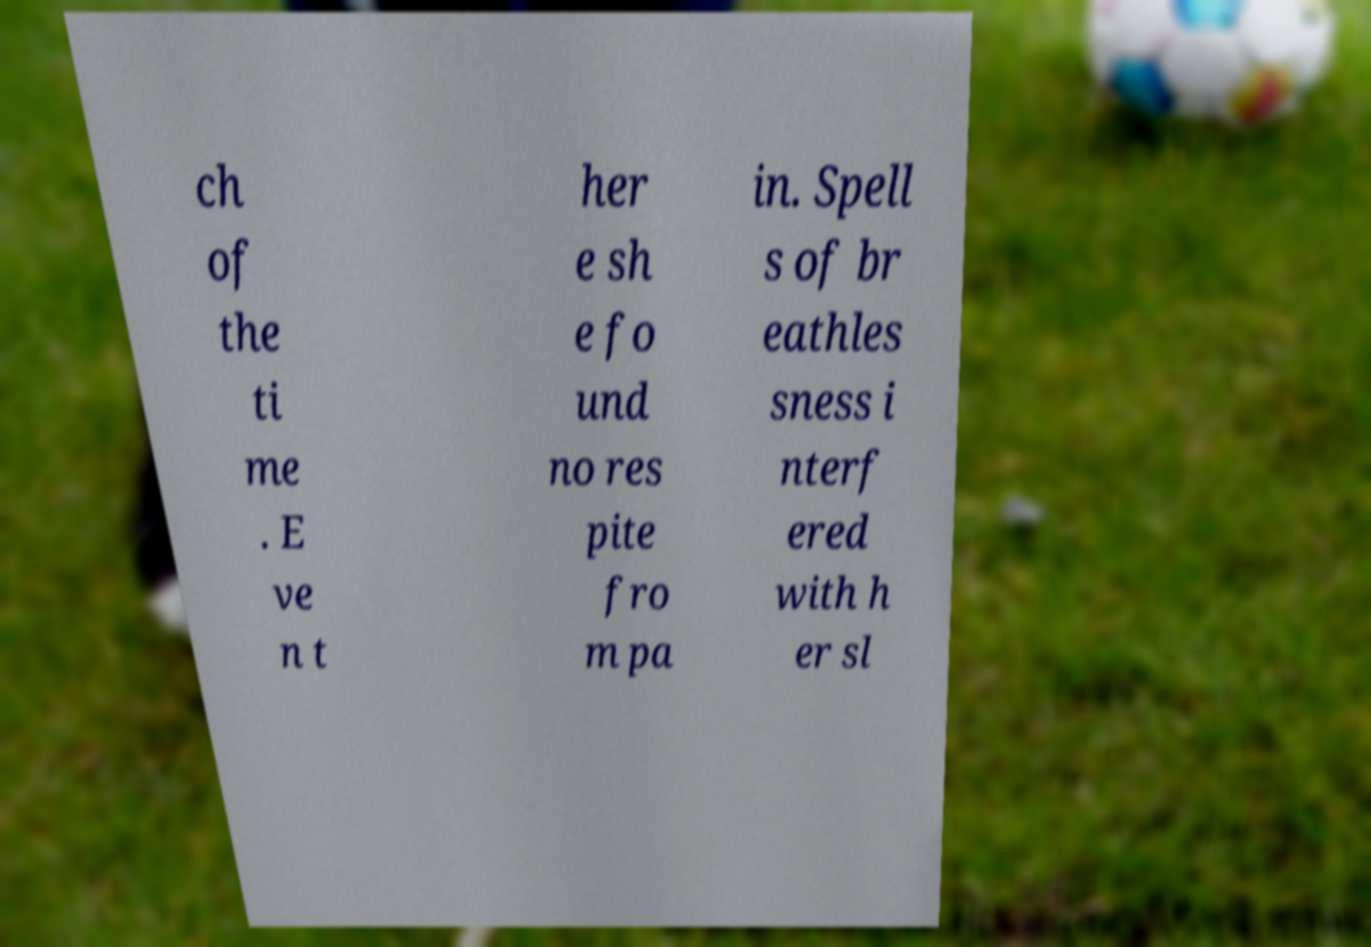Can you accurately transcribe the text from the provided image for me? ch of the ti me . E ve n t her e sh e fo und no res pite fro m pa in. Spell s of br eathles sness i nterf ered with h er sl 